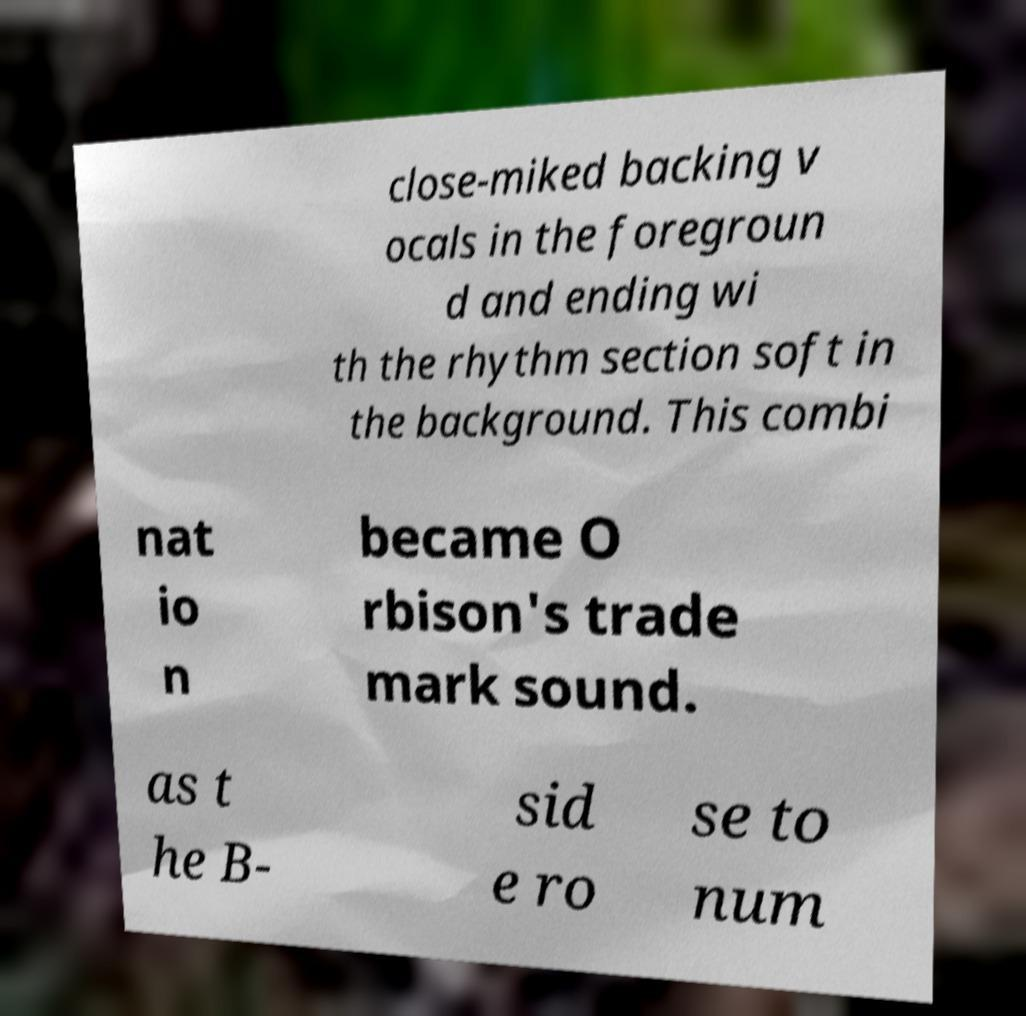For documentation purposes, I need the text within this image transcribed. Could you provide that? close-miked backing v ocals in the foregroun d and ending wi th the rhythm section soft in the background. This combi nat io n became O rbison's trade mark sound. as t he B- sid e ro se to num 